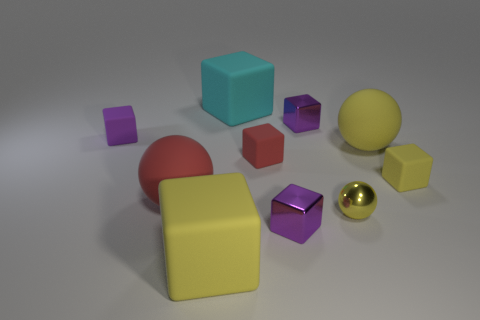Subtract all gray cylinders. How many purple cubes are left? 3 Subtract all cyan cubes. How many cubes are left? 6 Subtract all red matte blocks. How many blocks are left? 6 Subtract 2 cubes. How many cubes are left? 5 Subtract all blue cubes. Subtract all purple balls. How many cubes are left? 7 Subtract all spheres. How many objects are left? 7 Add 3 large cyan objects. How many large cyan objects are left? 4 Add 3 large gray matte cubes. How many large gray matte cubes exist? 3 Subtract 0 yellow cylinders. How many objects are left? 10 Subtract all small purple shiny objects. Subtract all red balls. How many objects are left? 7 